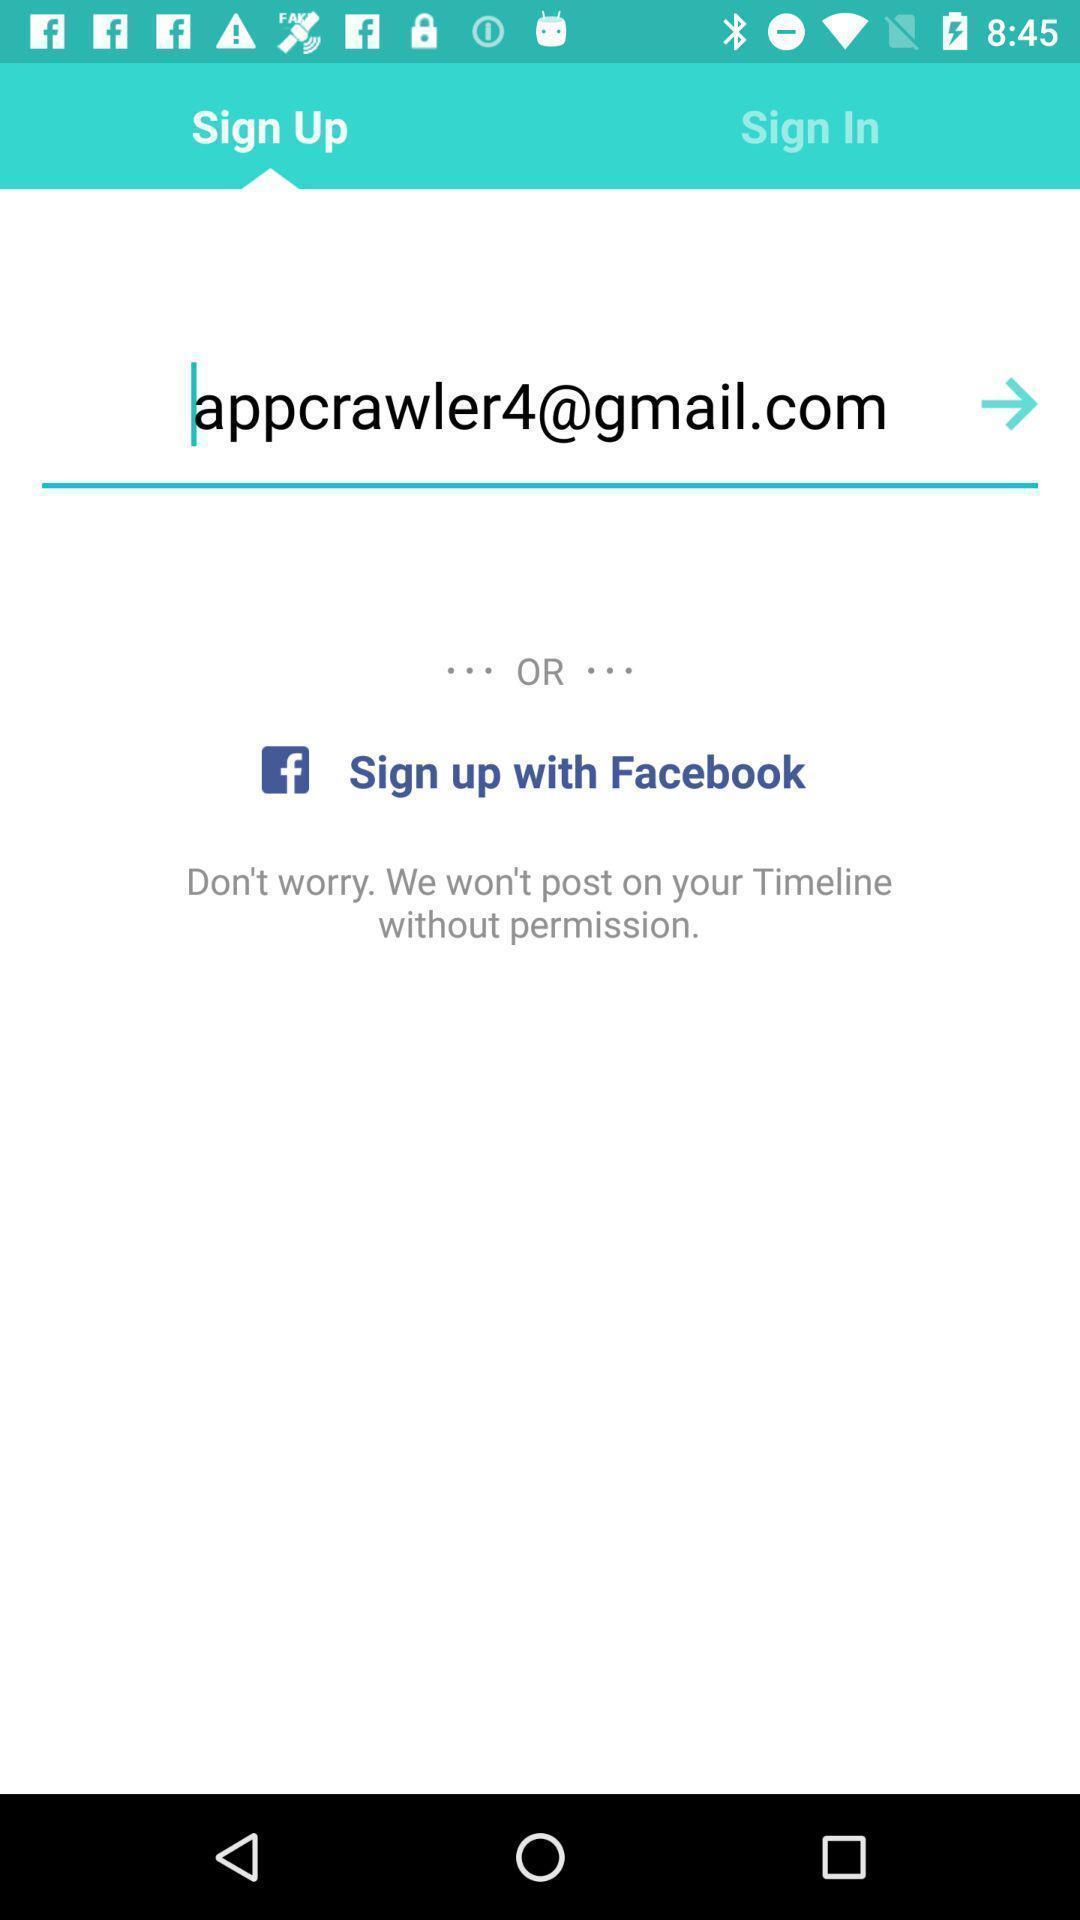What details can you identify in this image? Sign-up page for a app. 